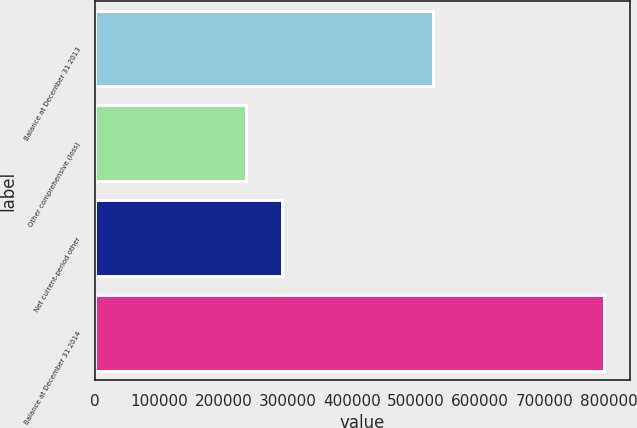Convert chart to OTSL. <chart><loc_0><loc_0><loc_500><loc_500><bar_chart><fcel>Balance at December 31 2013<fcel>Other comprehensive (loss)<fcel>Net current-period other<fcel>Balance at December 31 2014<nl><fcel>526071<fcel>235000<fcel>290808<fcel>793082<nl></chart> 